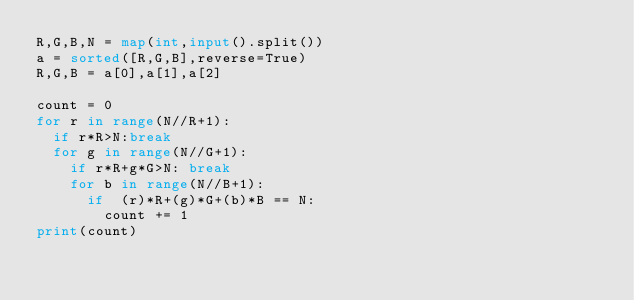Convert code to text. <code><loc_0><loc_0><loc_500><loc_500><_Python_>R,G,B,N = map(int,input().split())
a = sorted([R,G,B],reverse=True) 
R,G,B = a[0],a[1],a[2]

count = 0
for r in range(N//R+1):
  if r*R>N:break
  for g in range(N//G+1):
    if r*R+g*G>N: break
    for b in range(N//B+1):
      if  (r)*R+(g)*G+(b)*B == N:
        count += 1
print(count)
        
</code> 